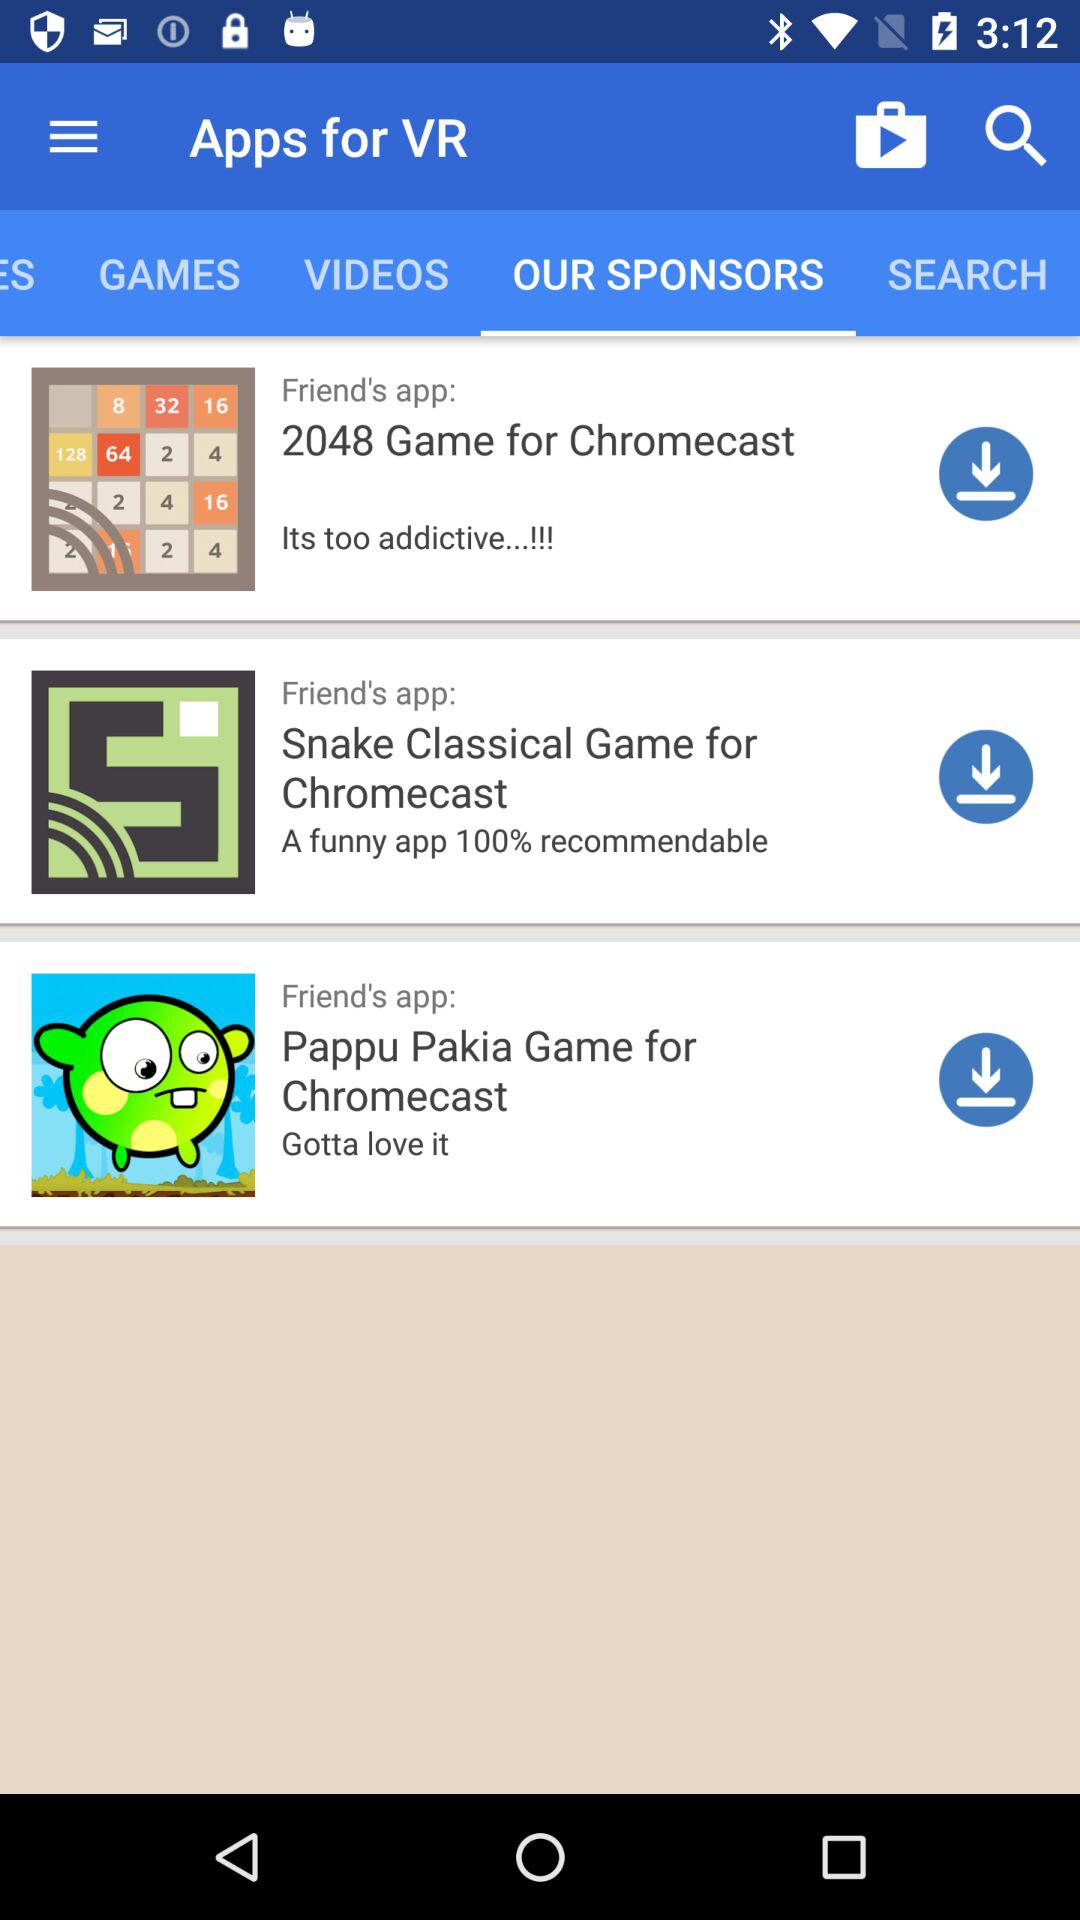How many apps are recommended by friends?
Answer the question using a single word or phrase. 3 